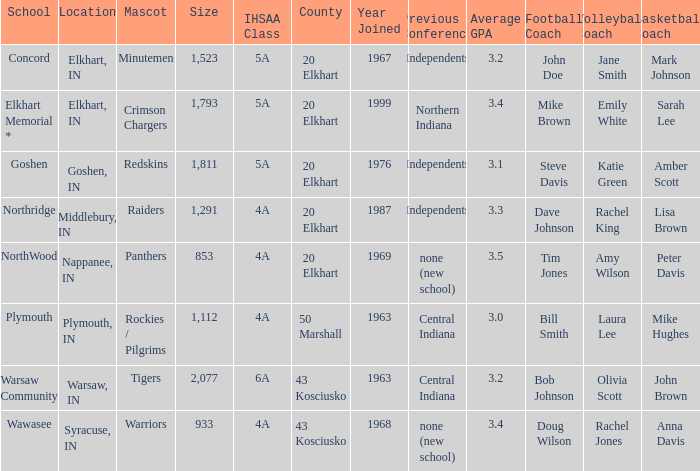What is the size of the team that was previously from Central Indiana conference, and is in IHSSA Class 4a? 1112.0. 